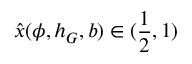Convert formula to latex. <formula><loc_0><loc_0><loc_500><loc_500>\hat { x } ( \phi , h _ { G } , b ) \in ( \frac { 1 } { 2 } , 1 )</formula> 